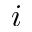<formula> <loc_0><loc_0><loc_500><loc_500>i</formula> 